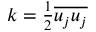Convert formula to latex. <formula><loc_0><loc_0><loc_500><loc_500>\begin{array} { r } { k = \frac { 1 } { 2 } \overline { { u _ { j } u _ { j } } } } \end{array}</formula> 